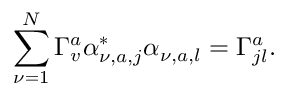<formula> <loc_0><loc_0><loc_500><loc_500>\sum _ { \nu = 1 } ^ { N } \Gamma _ { v } ^ { a } \alpha _ { \nu , a , j } ^ { * } \alpha _ { \nu , a , l } = \Gamma _ { j l } ^ { a } .</formula> 